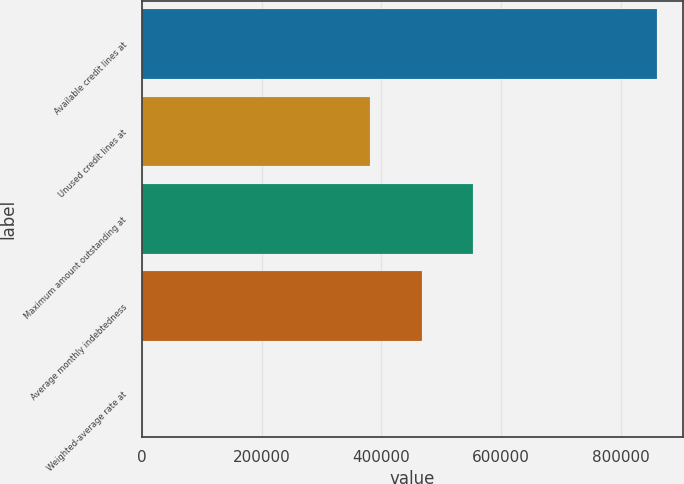Convert chart. <chart><loc_0><loc_0><loc_500><loc_500><bar_chart><fcel>Available credit lines at<fcel>Unused credit lines at<fcel>Maximum amount outstanding at<fcel>Average monthly indebtedness<fcel>Weighted-average rate at<nl><fcel>860000<fcel>381000<fcel>553000<fcel>467000<fcel>1.59<nl></chart> 